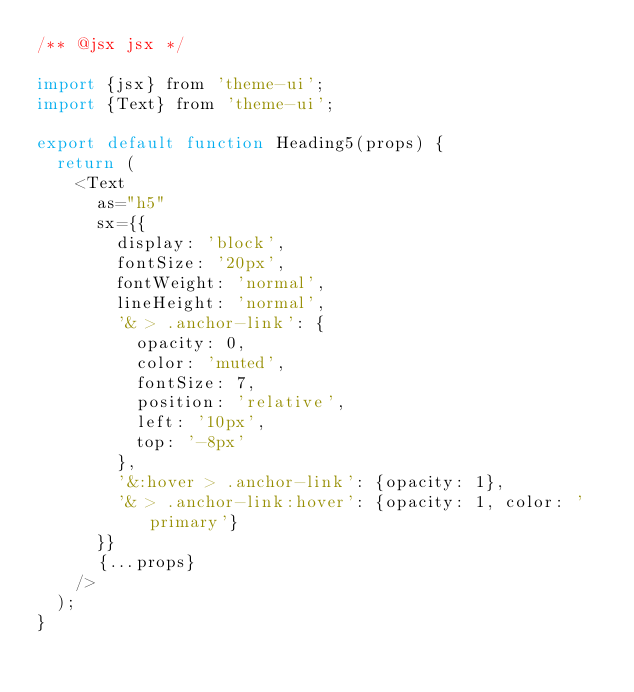Convert code to text. <code><loc_0><loc_0><loc_500><loc_500><_JavaScript_>/** @jsx jsx */

import {jsx} from 'theme-ui';
import {Text} from 'theme-ui';

export default function Heading5(props) {
  return (
    <Text
      as="h5"
      sx={{
        display: 'block',
        fontSize: '20px',
        fontWeight: 'normal',
        lineHeight: 'normal',
        '& > .anchor-link': {
          opacity: 0,
          color: 'muted',
          fontSize: 7,
          position: 'relative',
          left: '10px',
          top: '-8px'
        },
        '&:hover > .anchor-link': {opacity: 1},
        '& > .anchor-link:hover': {opacity: 1, color: 'primary'}
      }}
      {...props}
    />
  );
}
</code> 